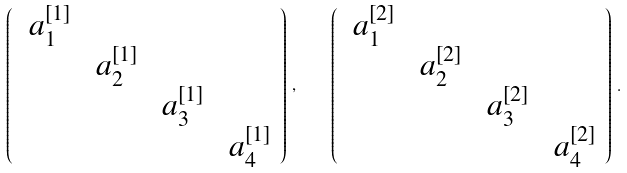<formula> <loc_0><loc_0><loc_500><loc_500>\left ( \begin{array} { c c c c } \ a ^ { [ 1 ] } _ { 1 } & & & \\ & \ a ^ { [ 1 ] } _ { 2 } & & \\ & & \ a ^ { [ 1 ] } _ { 3 } & \\ & & & \ a ^ { [ 1 ] } _ { 4 } \\ \end{array} \right ) \, , \quad \left ( \begin{array} { c c c c } \ a ^ { [ 2 ] } _ { 1 } & & & \\ & \ a ^ { [ 2 ] } _ { 2 } & & \\ & & \ a ^ { [ 2 ] } _ { 3 } & \\ & & & \ a ^ { [ 2 ] } _ { 4 } \\ \end{array} \right ) \, .</formula> 